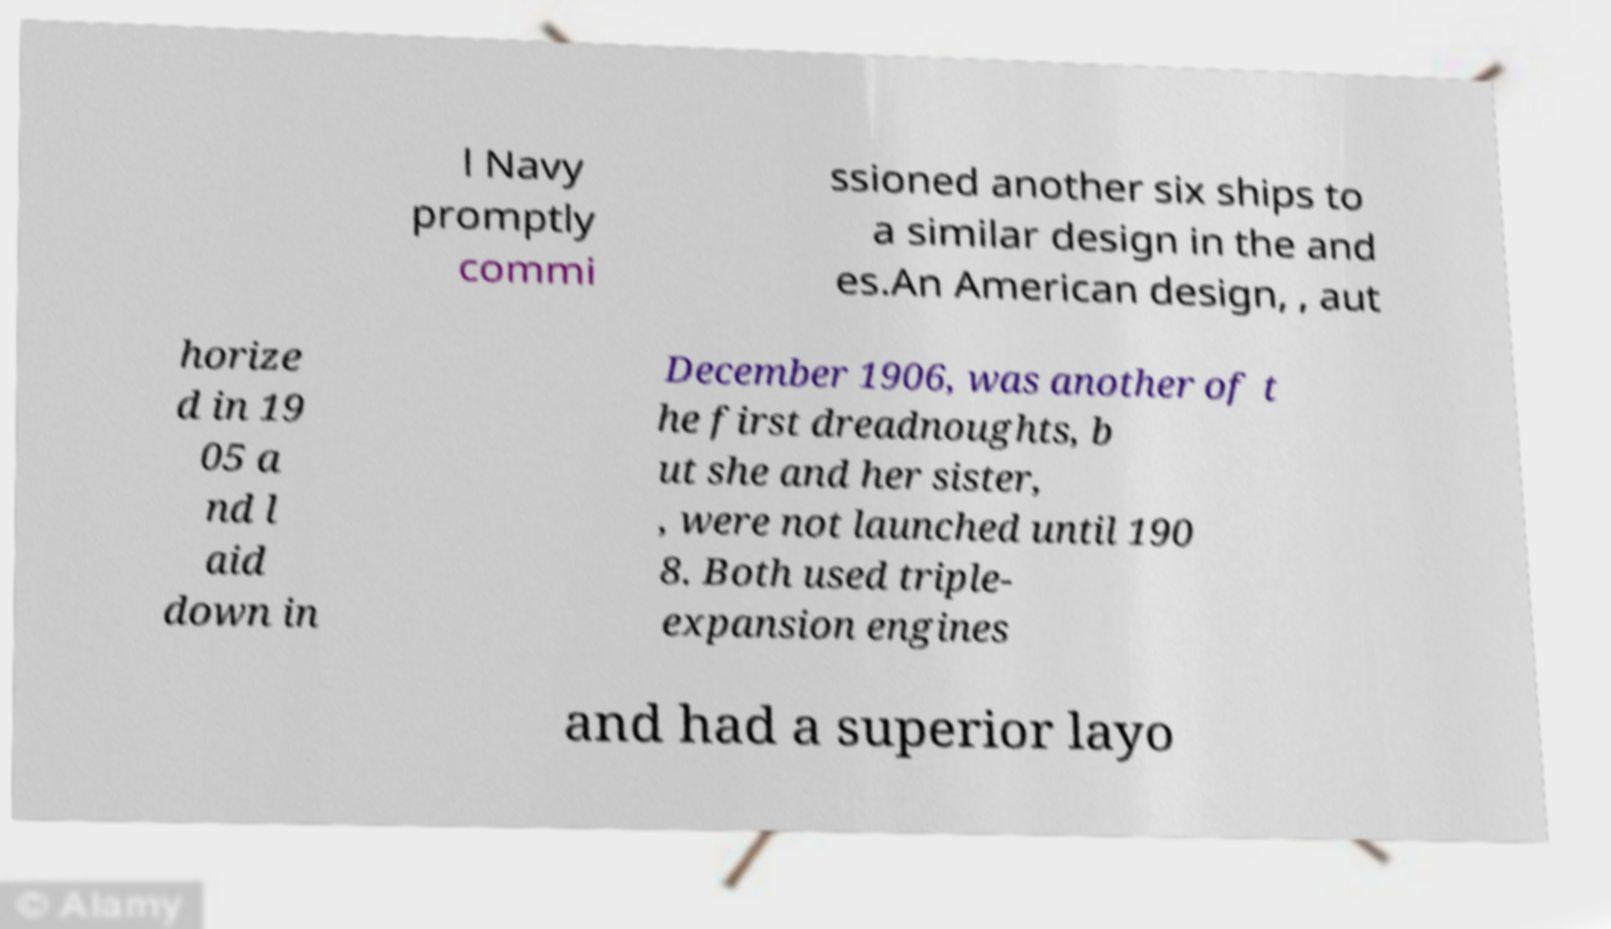Please identify and transcribe the text found in this image. l Navy promptly commi ssioned another six ships to a similar design in the and es.An American design, , aut horize d in 19 05 a nd l aid down in December 1906, was another of t he first dreadnoughts, b ut she and her sister, , were not launched until 190 8. Both used triple- expansion engines and had a superior layo 